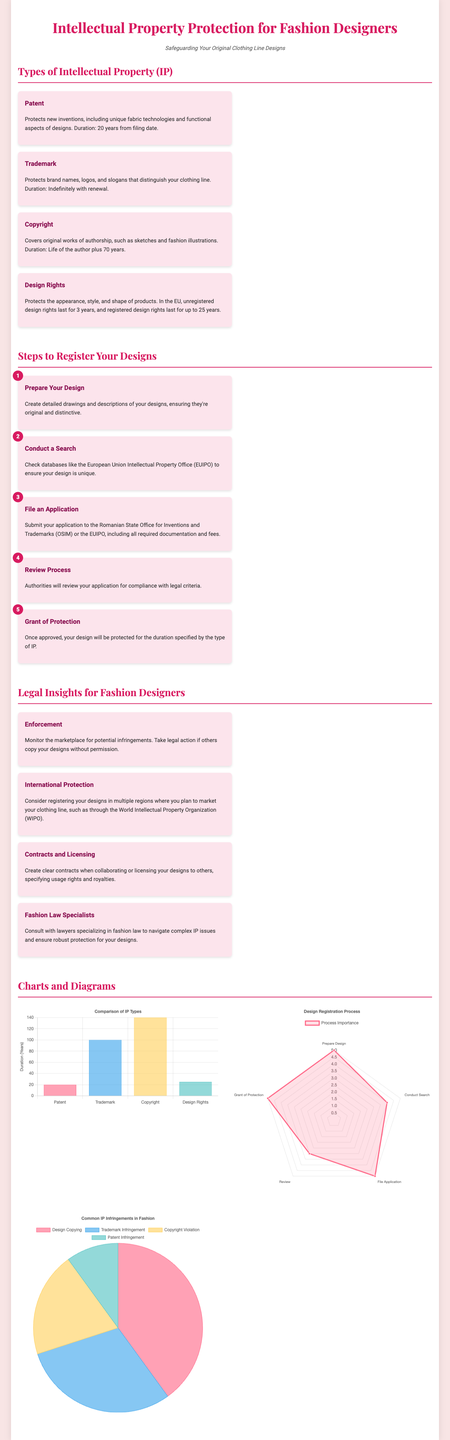What is the duration of a patent? A patent lasts for 20 years from the filing date, as stated in the document under the patent section.
Answer: 20 years What does a trademark protect? The trademark protects brand names, logos, and slogans, according to the trademark section in the document.
Answer: Brand names, logos, and slogans How long do unregistered design rights last in the EU? The document mentions that unregistered design rights last for 3 years in the EU.
Answer: 3 years How many steps are there to register designs? The steps to register designs are outlined in the document, which lists five distinct steps.
Answer: 5 What type of chart compares different IP types? The bar chart displays a comparison of IP types based on their duration in years, as described in the charts section.
Answer: Bar chart In the design registration process, which step has the highest importance rating? The document indicates that "Prepare Design" and "File Application" both have a rating of 5, making them the highest.
Answer: 5 What percentage of common infringements is design copying? The pie chart shows that design copying constitutes 40% of common IP infringements in fashion.
Answer: 40% What is the life duration of copyright protection? The copyright section states that it lasts for the life of the author plus 70 years.
Answer: Life of the author plus 70 years Which legal aspect involves creating contracts with collaborators? The insights section highlights that contracts and licensing involve specifying usage rights and royalties.
Answer: Contracts and licensing 